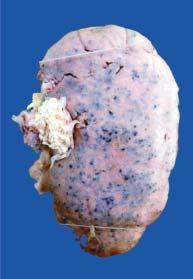does the cortex show characteristic 'flea bitten kidney ' due to tiny petechial haemorrhages on the surface?
Answer the question using a single word or phrase. Yes 